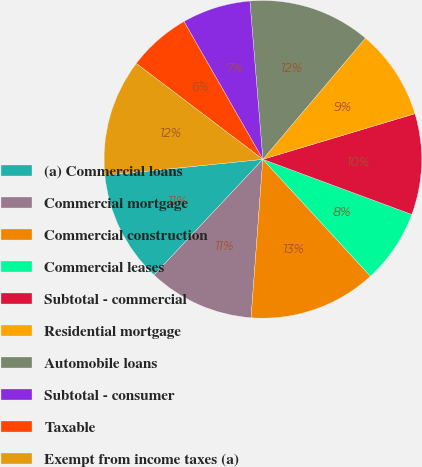Convert chart. <chart><loc_0><loc_0><loc_500><loc_500><pie_chart><fcel>(a) Commercial loans<fcel>Commercial mortgage<fcel>Commercial construction<fcel>Commercial leases<fcel>Subtotal - commercial<fcel>Residential mortgage<fcel>Automobile loans<fcel>Subtotal - consumer<fcel>Taxable<fcel>Exempt from income taxes (a)<nl><fcel>11.37%<fcel>10.83%<fcel>13.02%<fcel>7.52%<fcel>10.28%<fcel>9.18%<fcel>12.48%<fcel>6.97%<fcel>6.41%<fcel>11.93%<nl></chart> 